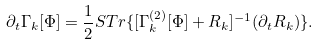<formula> <loc_0><loc_0><loc_500><loc_500>\partial _ { t } \Gamma _ { k } [ \Phi ] = \frac { 1 } { 2 } S T r \{ [ \Gamma ^ { ( 2 ) } _ { k } [ \Phi ] + R _ { k } ] ^ { - 1 } ( \partial _ { t } R _ { k } ) \} .</formula> 